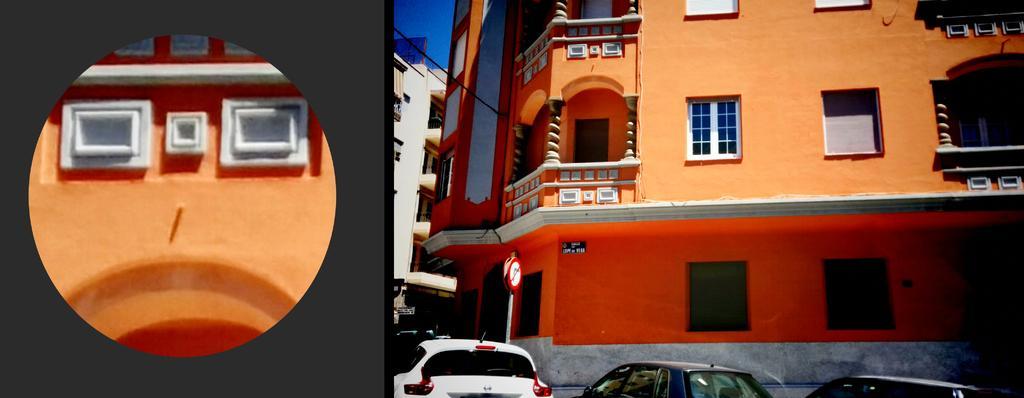Please provide a concise description of this image. This is an edited image. We can see there are buildings, a cable and the sky. At the bottom of the image there are vehicles and there is a pole with boards attached to it. On the left side of the image, there is a zoomed part of an orange building. 